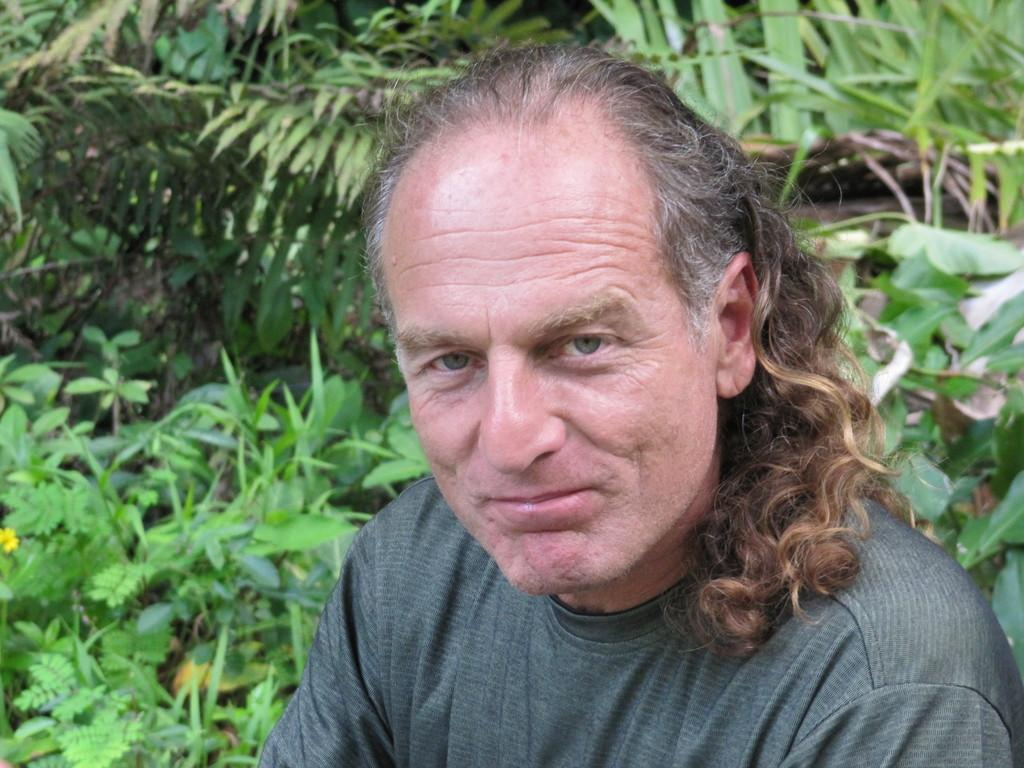Who or what is present in the image? There is a person in the image. What else can be seen in the image besides the person? There are many plants in the image. Can you describe a specific plant in the image? There is a flower on a plant at the left side of the image. What caused the eggs to smash in the image? There are no eggs present in the image, so it is not possible to determine what caused them to smash. 